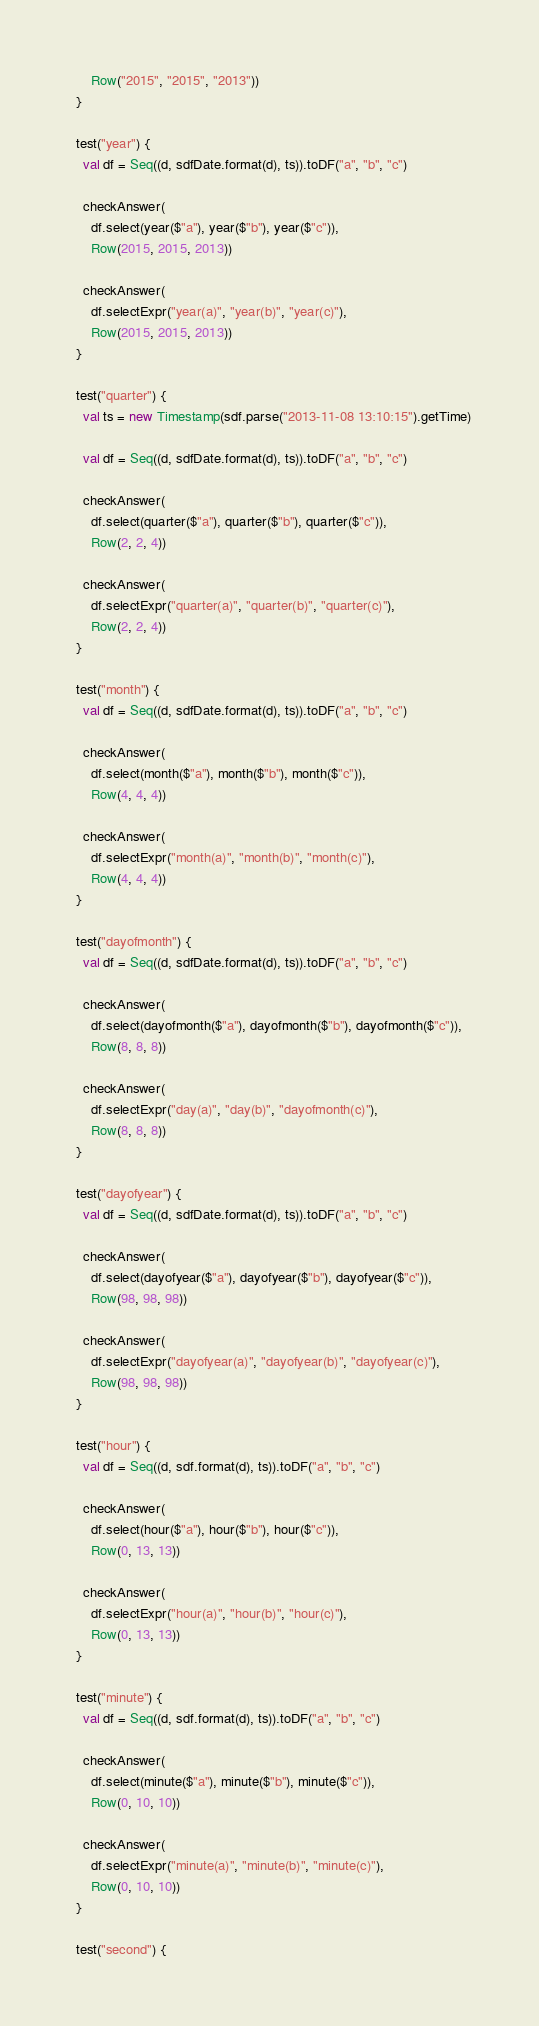<code> <loc_0><loc_0><loc_500><loc_500><_Scala_>      Row("2015", "2015", "2013"))
  }

  test("year") {
    val df = Seq((d, sdfDate.format(d), ts)).toDF("a", "b", "c")

    checkAnswer(
      df.select(year($"a"), year($"b"), year($"c")),
      Row(2015, 2015, 2013))

    checkAnswer(
      df.selectExpr("year(a)", "year(b)", "year(c)"),
      Row(2015, 2015, 2013))
  }

  test("quarter") {
    val ts = new Timestamp(sdf.parse("2013-11-08 13:10:15").getTime)

    val df = Seq((d, sdfDate.format(d), ts)).toDF("a", "b", "c")

    checkAnswer(
      df.select(quarter($"a"), quarter($"b"), quarter($"c")),
      Row(2, 2, 4))

    checkAnswer(
      df.selectExpr("quarter(a)", "quarter(b)", "quarter(c)"),
      Row(2, 2, 4))
  }

  test("month") {
    val df = Seq((d, sdfDate.format(d), ts)).toDF("a", "b", "c")

    checkAnswer(
      df.select(month($"a"), month($"b"), month($"c")),
      Row(4, 4, 4))

    checkAnswer(
      df.selectExpr("month(a)", "month(b)", "month(c)"),
      Row(4, 4, 4))
  }

  test("dayofmonth") {
    val df = Seq((d, sdfDate.format(d), ts)).toDF("a", "b", "c")

    checkAnswer(
      df.select(dayofmonth($"a"), dayofmonth($"b"), dayofmonth($"c")),
      Row(8, 8, 8))

    checkAnswer(
      df.selectExpr("day(a)", "day(b)", "dayofmonth(c)"),
      Row(8, 8, 8))
  }

  test("dayofyear") {
    val df = Seq((d, sdfDate.format(d), ts)).toDF("a", "b", "c")

    checkAnswer(
      df.select(dayofyear($"a"), dayofyear($"b"), dayofyear($"c")),
      Row(98, 98, 98))

    checkAnswer(
      df.selectExpr("dayofyear(a)", "dayofyear(b)", "dayofyear(c)"),
      Row(98, 98, 98))
  }

  test("hour") {
    val df = Seq((d, sdf.format(d), ts)).toDF("a", "b", "c")

    checkAnswer(
      df.select(hour($"a"), hour($"b"), hour($"c")),
      Row(0, 13, 13))

    checkAnswer(
      df.selectExpr("hour(a)", "hour(b)", "hour(c)"),
      Row(0, 13, 13))
  }

  test("minute") {
    val df = Seq((d, sdf.format(d), ts)).toDF("a", "b", "c")

    checkAnswer(
      df.select(minute($"a"), minute($"b"), minute($"c")),
      Row(0, 10, 10))

    checkAnswer(
      df.selectExpr("minute(a)", "minute(b)", "minute(c)"),
      Row(0, 10, 10))
  }

  test("second") {</code> 